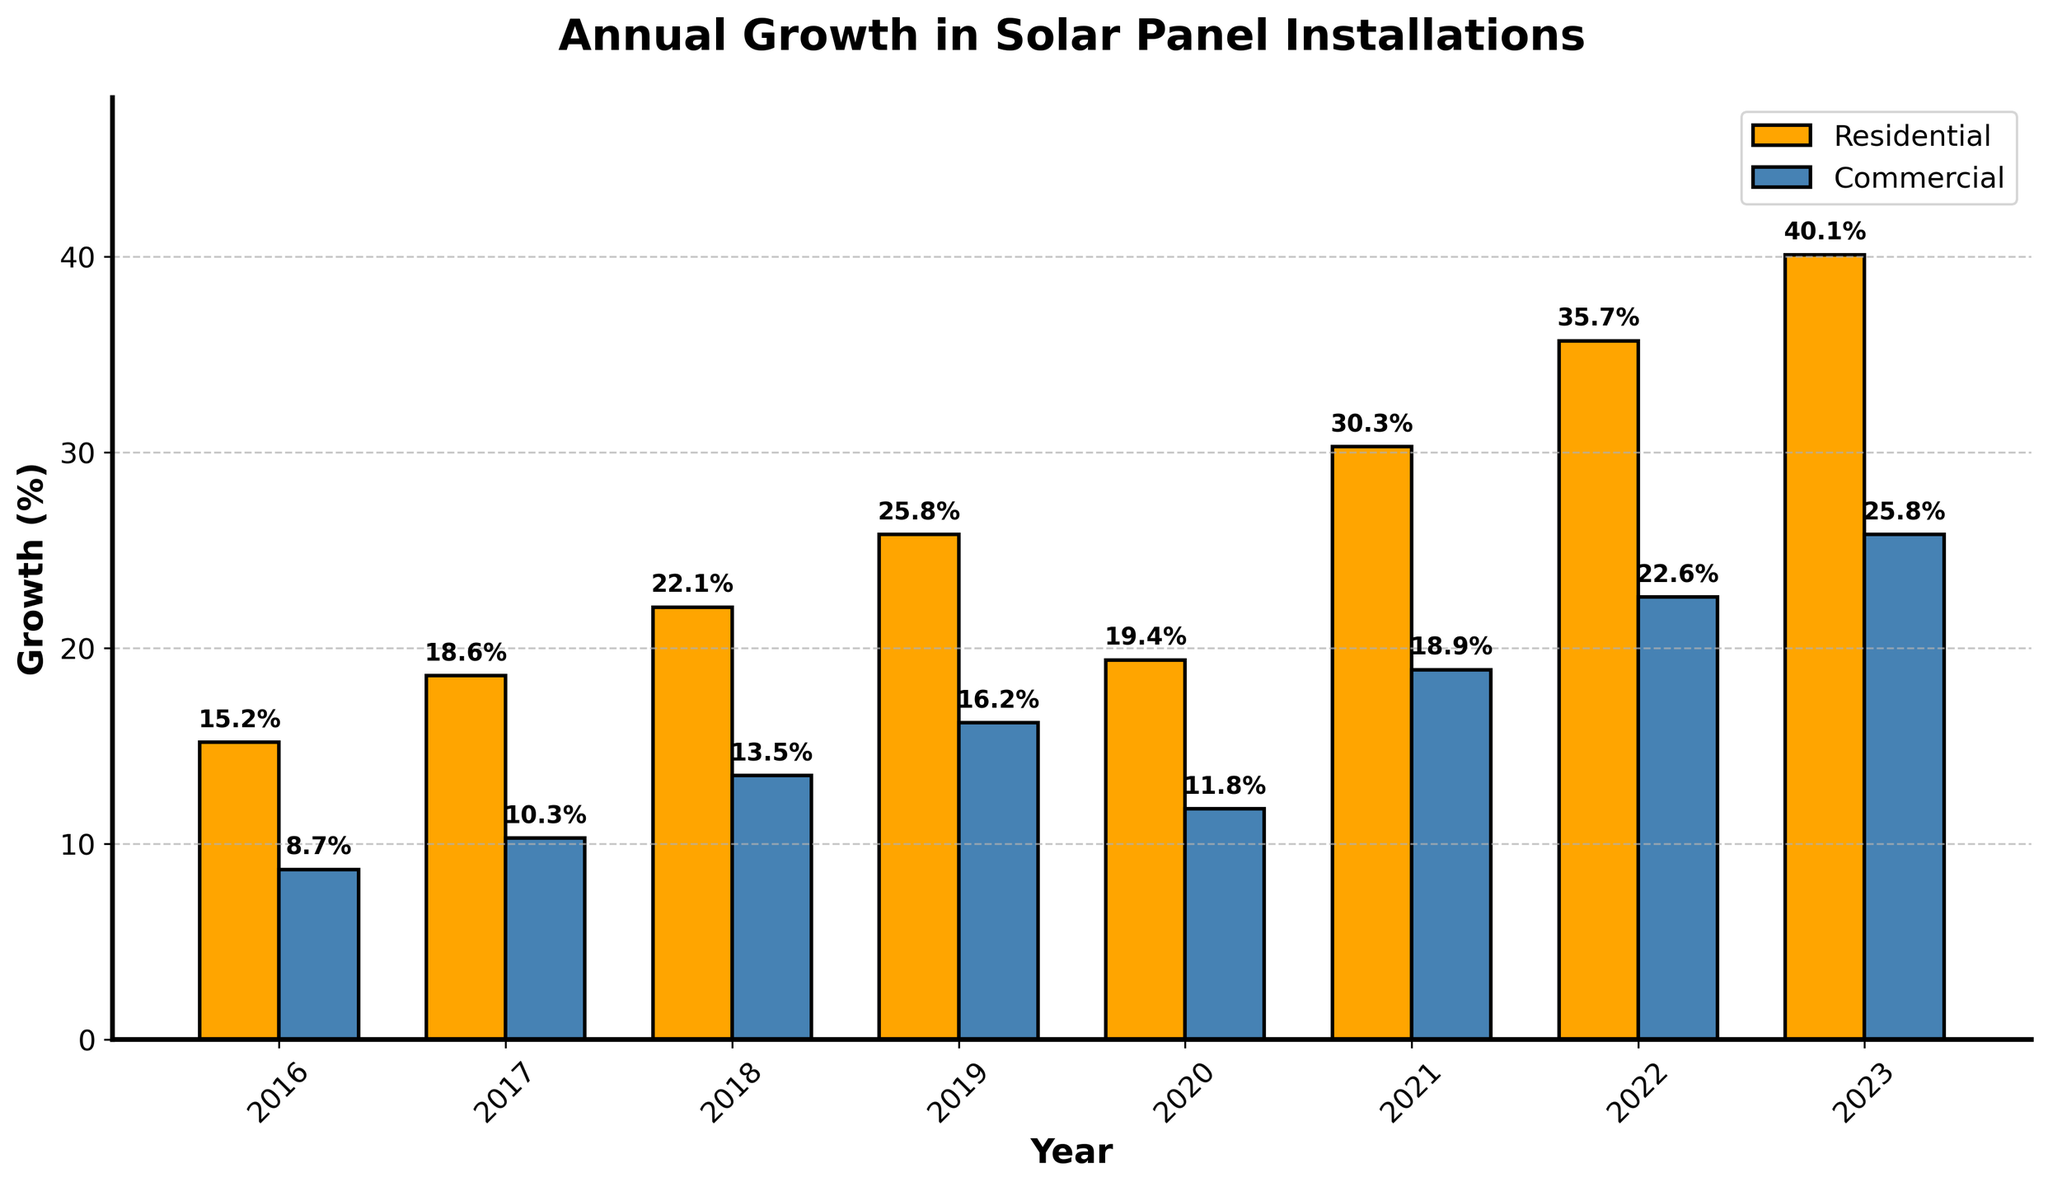What sector had the highest growth rate in 2023? From the figure, the highest bar in 2023 corresponds to the residential sector.
Answer: Residential sector In which year did the commercial sector show its highest growth rate? By looking at the heights of the blue bars, the highest value for the commercial sector is in 2023.
Answer: 2023 Comparing 2020 and 2021, which sector showed a greater increase in growth rate? The residential sector increased from 19.4% in 2020 to 30.3% in 2021, a rise of 10.9%. The commercial sector increased from 11.8% in 2020 to 18.9% in 2021, a rise of 7.1%. Therefore, the residential sector had a greater increase.
Answer: Residential sector How much higher is the growth rate for the residential sector than the commercial sector in 2023? The residential growth rate in 2023 is 40.1%, and the commercial growth rate is 25.8%. The difference is 40.1% - 25.8% = 14.3%.
Answer: 14.3% What is the average annual growth rate for the residential sector between 2016 and 2023? Adding the growth rates for the residential sector from 2016 to 2023 (15.2% + 18.6% + 22.1% + 25.8% + 19.4% + 30.3% + 35.7% + 40.1%) gives 207.2%. Dividing by the 8 years, the average is 207.2% / 8 = 25.9%.
Answer: 25.9% Which year experienced the smallest growth difference between the residential and commercial sectors? Subtracting commercial growth percentages from residential percentages for each year: 2016 (15.2% - 8.7% = 6.5%), 2017 (18.6% - 10.3% = 8.3%), 2018 (22.1% - 13.5% = 8.6%), 2019 (25.8% - 16.2% = 9.6%), 2020 (19.4% - 11.8% = 7.6%), 2021 (30.3% - 18.9% = 11.4%), 2022 (35.7% - 22.6% = 13.1%), 2023 (40.1% - 25.8% = 14.3%). The smallest difference is in 2016 with 6.5%.
Answer: 2016 What is the overall trend in the growth rates for both sectors over the years? Both residential and commercial sectors show an increasing trend in growth rates from 2016 to 2023, despite some fluctuations.
Answer: Increasing trend In 2018, what is the combined growth rate for both sectors? Adding the growth rates for residential (22.1%) and commercial (13.5%) in 2018 gives 22.1% + 13.5% = 35.6%.
Answer: 35.6% By what percentage did the residential sector's growth rate change from 2022 to 2023? The residential growth rate in 2022 was 35.7% and in 2023 it was 40.1%. The change is (40.1% - 35.7%) = 4.4%.
Answer: 4.4% 